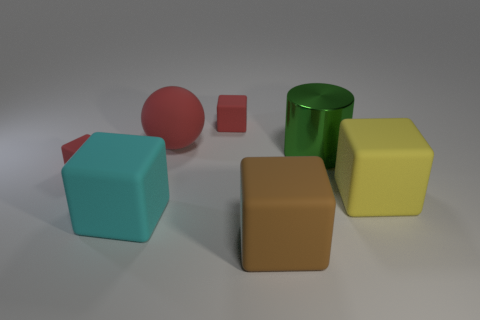Subtract 3 blocks. How many blocks are left? 2 Add 1 large purple metal cylinders. How many objects exist? 8 Subtract all brown cubes. How many cubes are left? 4 Add 4 small red rubber blocks. How many small red rubber blocks exist? 6 Subtract all brown cubes. How many cubes are left? 4 Subtract 0 green blocks. How many objects are left? 7 Subtract all cubes. How many objects are left? 2 Subtract all purple blocks. Subtract all yellow spheres. How many blocks are left? 5 Subtract all purple cylinders. How many gray balls are left? 0 Subtract all red cubes. Subtract all red matte spheres. How many objects are left? 4 